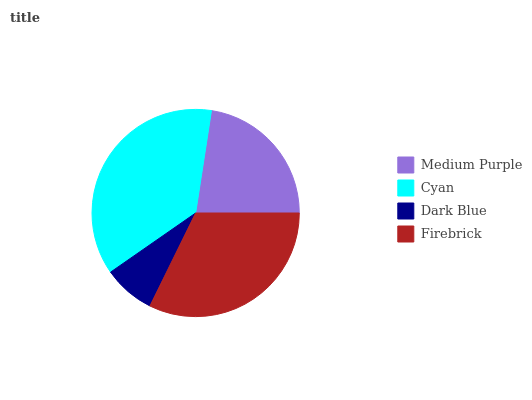Is Dark Blue the minimum?
Answer yes or no. Yes. Is Cyan the maximum?
Answer yes or no. Yes. Is Cyan the minimum?
Answer yes or no. No. Is Dark Blue the maximum?
Answer yes or no. No. Is Cyan greater than Dark Blue?
Answer yes or no. Yes. Is Dark Blue less than Cyan?
Answer yes or no. Yes. Is Dark Blue greater than Cyan?
Answer yes or no. No. Is Cyan less than Dark Blue?
Answer yes or no. No. Is Firebrick the high median?
Answer yes or no. Yes. Is Medium Purple the low median?
Answer yes or no. Yes. Is Medium Purple the high median?
Answer yes or no. No. Is Dark Blue the low median?
Answer yes or no. No. 